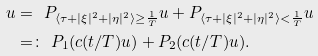<formula> <loc_0><loc_0><loc_500><loc_500>u & = \ P _ { \langle \tau + | \xi | ^ { 2 } + | \eta | ^ { 2 } \rangle \geq \frac { 1 } { T } } u + P _ { \langle \tau + | \xi | ^ { 2 } + | \eta | ^ { 2 } \rangle < \frac { 1 } { T } } u \\ & = \colon \ P _ { 1 } ( c ( t / T ) u ) + P _ { 2 } ( c ( t / T ) u ) .</formula> 